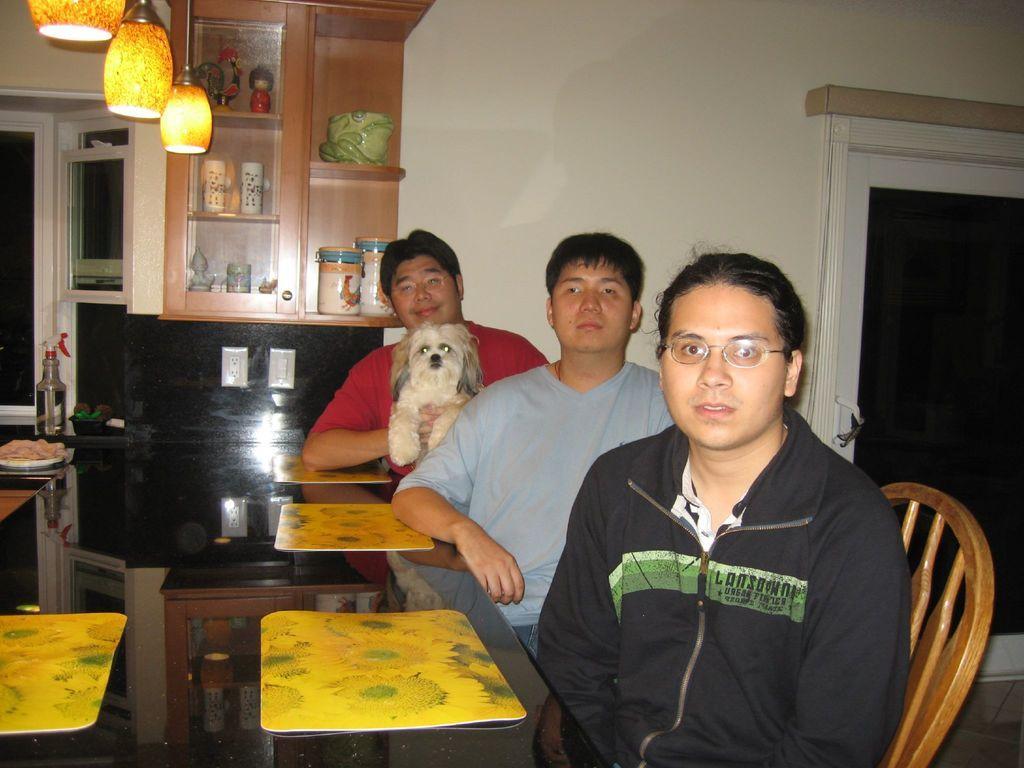Describe this image in one or two sentences. In the image we can see there are people who are sitting on the chair and in front of them there is a dining table and the man who is sitting in the back is holding a dog and on the top the lights which are hanging and the wall is off white colour. 